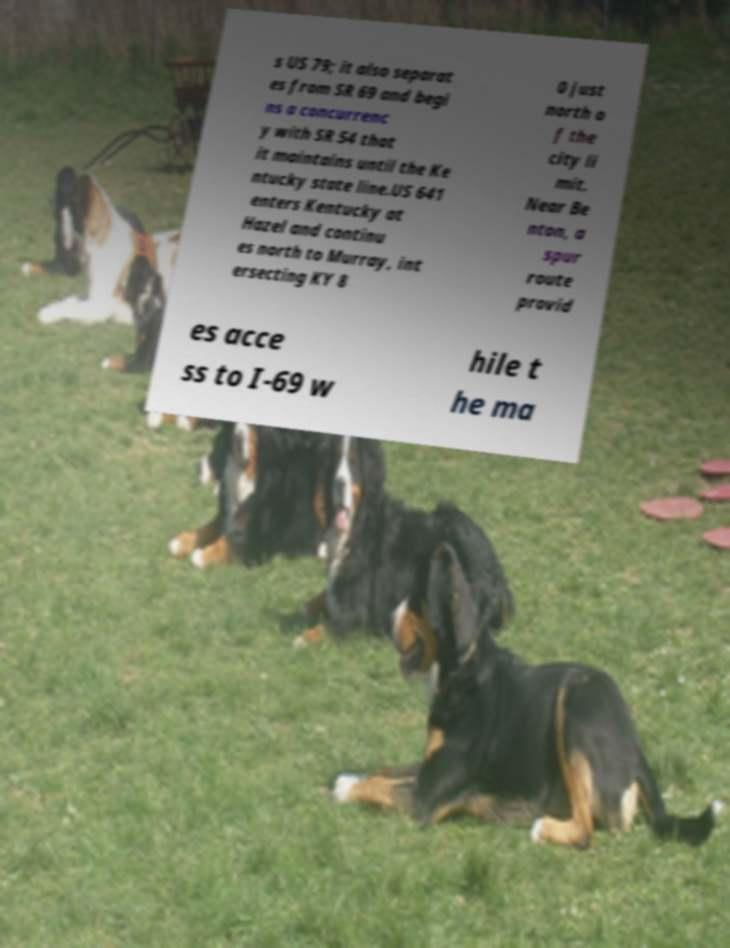Please read and relay the text visible in this image. What does it say? s US 79; it also separat es from SR 69 and begi ns a concurrenc y with SR 54 that it maintains until the Ke ntucky state line.US 641 enters Kentucky at Hazel and continu es north to Murray, int ersecting KY 8 0 just north o f the city li mit. Near Be nton, a spur route provid es acce ss to I-69 w hile t he ma 